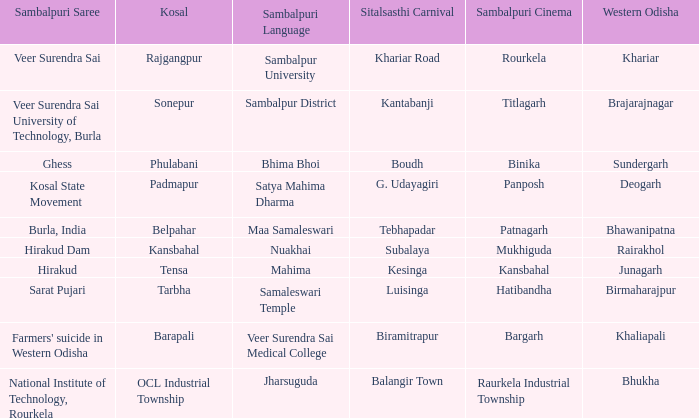Would you mind parsing the complete table? {'header': ['Sambalpuri Saree', 'Kosal', 'Sambalpuri Language', 'Sitalsasthi Carnival', 'Sambalpuri Cinema', 'Western Odisha'], 'rows': [['Veer Surendra Sai', 'Rajgangpur', 'Sambalpur University', 'Khariar Road', 'Rourkela', 'Khariar'], ['Veer Surendra Sai University of Technology, Burla', 'Sonepur', 'Sambalpur District', 'Kantabanji', 'Titlagarh', 'Brajarajnagar'], ['Ghess', 'Phulabani', 'Bhima Bhoi', 'Boudh', 'Binika', 'Sundergarh'], ['Kosal State Movement', 'Padmapur', 'Satya Mahima Dharma', 'G. Udayagiri', 'Panposh', 'Deogarh'], ['Burla, India', 'Belpahar', 'Maa Samaleswari', 'Tebhapadar', 'Patnagarh', 'Bhawanipatna'], ['Hirakud Dam', 'Kansbahal', 'Nuakhai', 'Subalaya', 'Mukhiguda', 'Rairakhol'], ['Hirakud', 'Tensa', 'Mahima', 'Kesinga', 'Kansbahal', 'Junagarh'], ['Sarat Pujari', 'Tarbha', 'Samaleswari Temple', 'Luisinga', 'Hatibandha', 'Birmaharajpur'], ["Farmers' suicide in Western Odisha", 'Barapali', 'Veer Surendra Sai Medical College', 'Biramitrapur', 'Bargarh', 'Khaliapali'], ['National Institute of Technology, Rourkela', 'OCL Industrial Township', 'Jharsuguda', 'Balangir Town', 'Raurkela Industrial Township', 'Bhukha']]} What is the sitalsasthi carnival with hirakud as sambalpuri saree? Kesinga. 